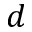<formula> <loc_0><loc_0><loc_500><loc_500>d</formula> 